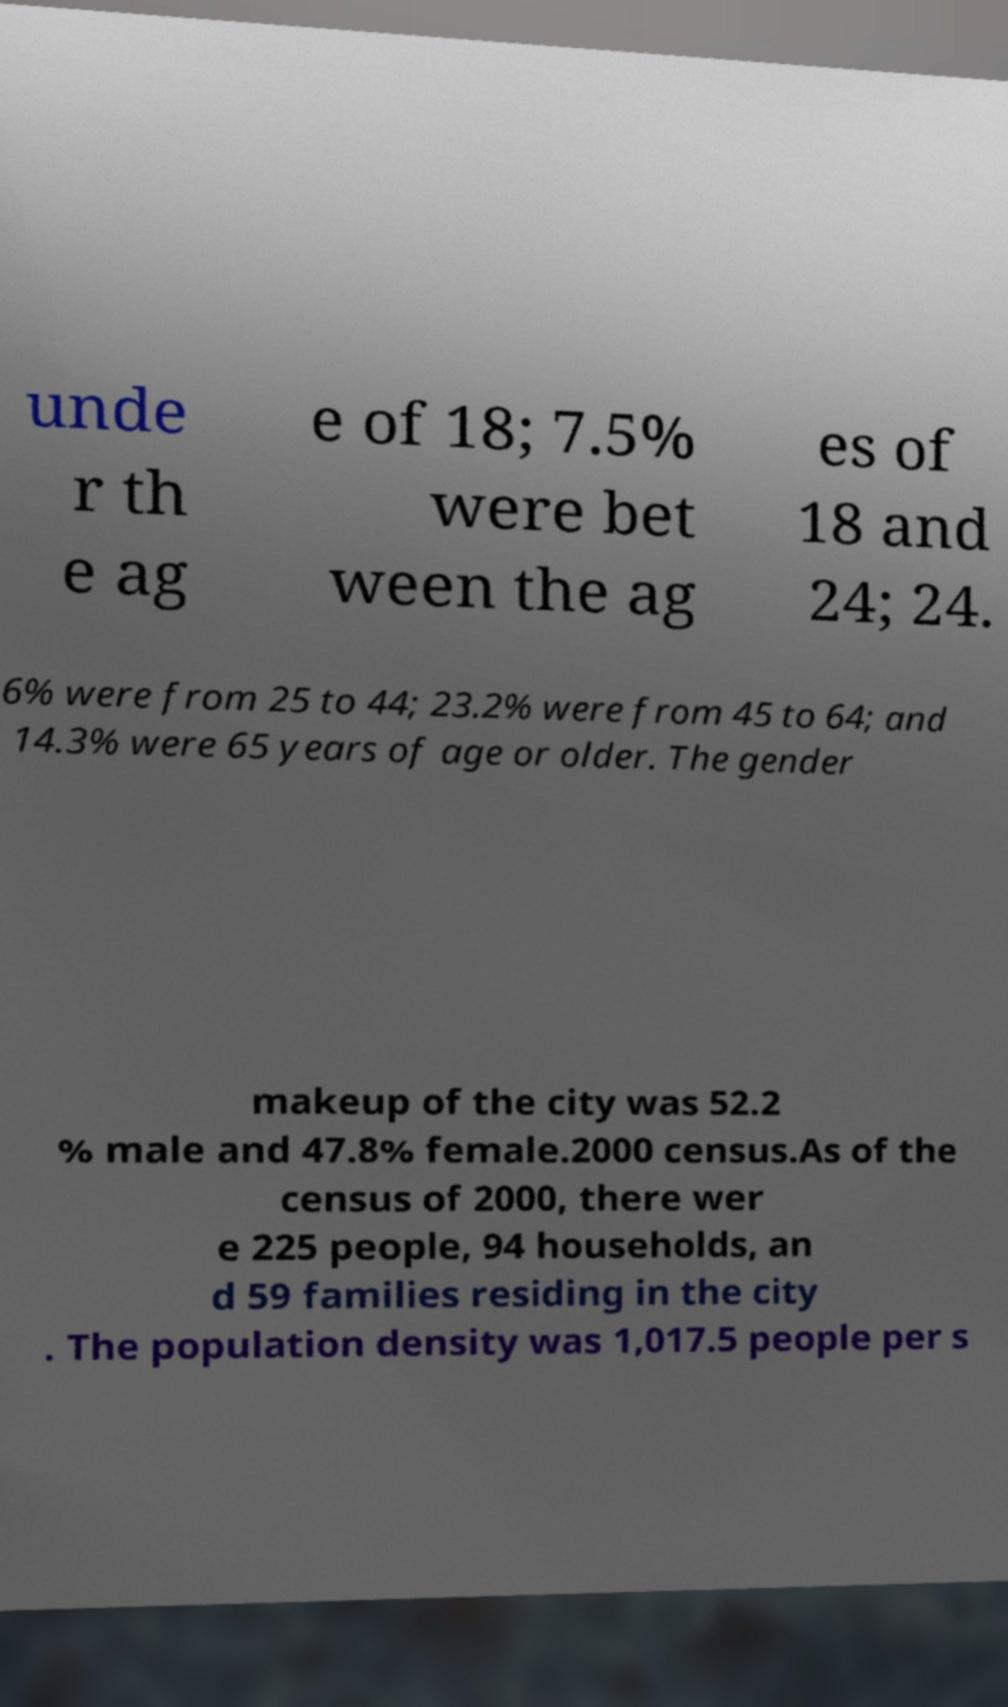Could you assist in decoding the text presented in this image and type it out clearly? unde r th e ag e of 18; 7.5% were bet ween the ag es of 18 and 24; 24. 6% were from 25 to 44; 23.2% were from 45 to 64; and 14.3% were 65 years of age or older. The gender makeup of the city was 52.2 % male and 47.8% female.2000 census.As of the census of 2000, there wer e 225 people, 94 households, an d 59 families residing in the city . The population density was 1,017.5 people per s 